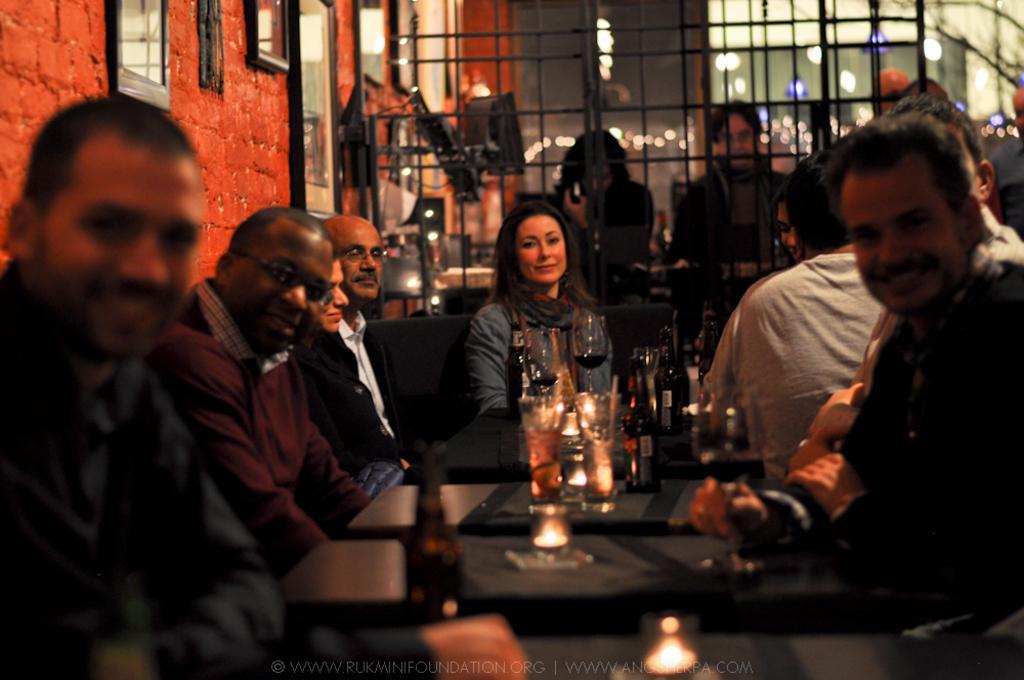Please provide a concise description of this image. In this picture there are tables in the center of the image, on which there are bottles and glasses on it, there are people those who are sitting around the table, there are portraits on the wall, there are other people, lights and a net in the background area of the image. 